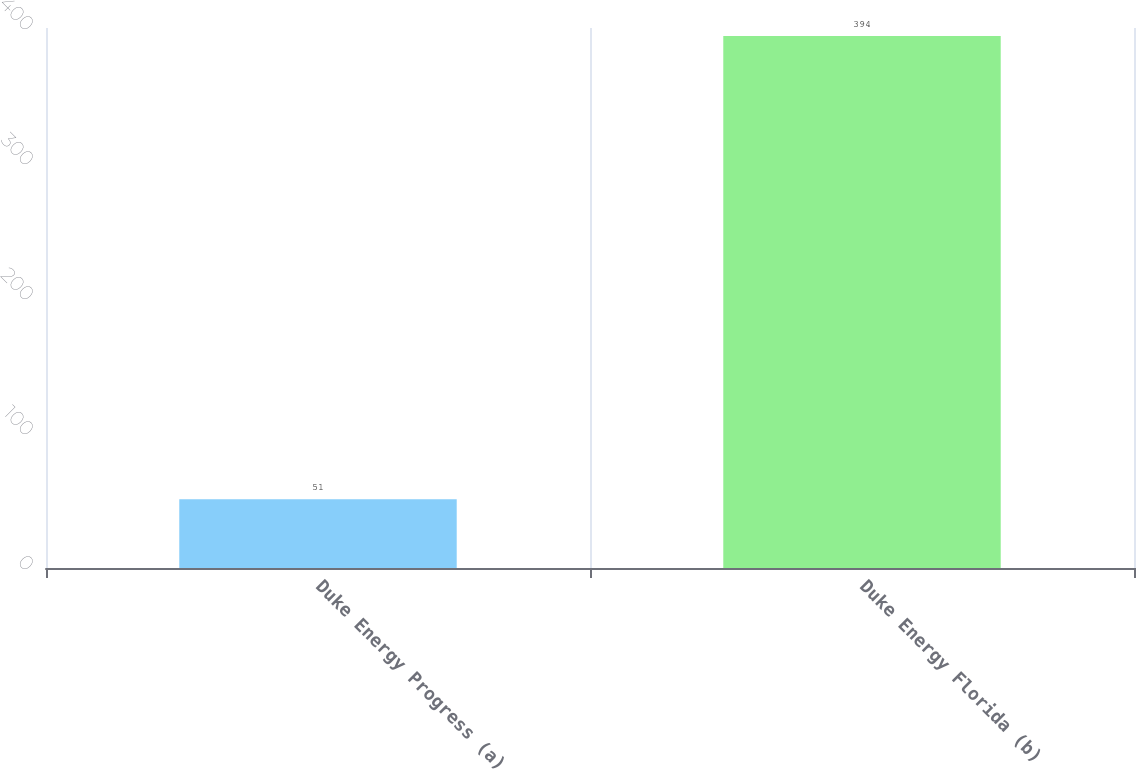Convert chart to OTSL. <chart><loc_0><loc_0><loc_500><loc_500><bar_chart><fcel>Duke Energy Progress (a)<fcel>Duke Energy Florida (b)<nl><fcel>51<fcel>394<nl></chart> 